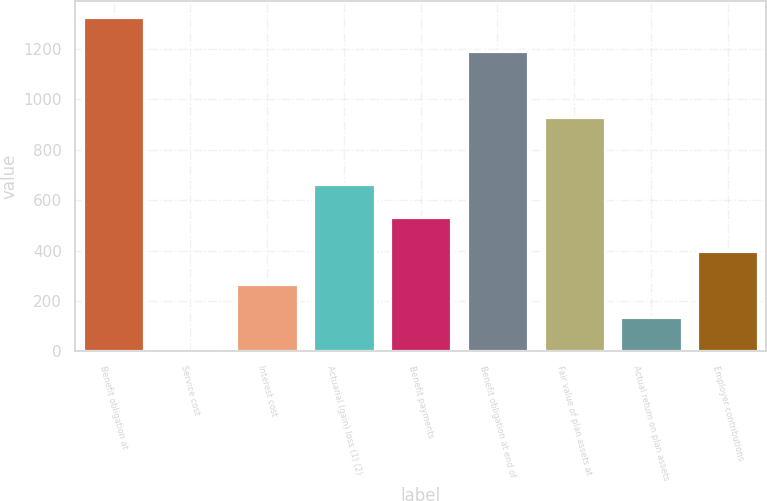Convert chart to OTSL. <chart><loc_0><loc_0><loc_500><loc_500><bar_chart><fcel>Benefit obligation at<fcel>Service cost<fcel>Interest cost<fcel>Actuarial (gain) loss (1) (2)<fcel>Benefit payments<fcel>Benefit obligation at end of<fcel>Fair value of plan assets at<fcel>Actual return on plan assets<fcel>Employer contributions<nl><fcel>1325<fcel>3<fcel>267.4<fcel>664<fcel>531.8<fcel>1192.8<fcel>928.4<fcel>135.2<fcel>399.6<nl></chart> 